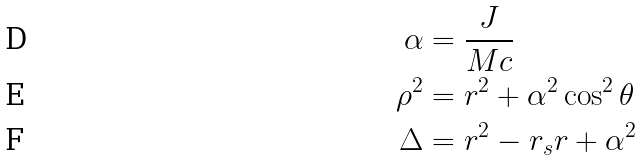Convert formula to latex. <formula><loc_0><loc_0><loc_500><loc_500>\alpha & = \frac { J } { M c } \\ \rho ^ { 2 } & = r ^ { 2 } + \alpha ^ { 2 } \cos ^ { 2 } \theta \\ \Delta & = r ^ { 2 } - r _ { s } r + \alpha ^ { 2 }</formula> 